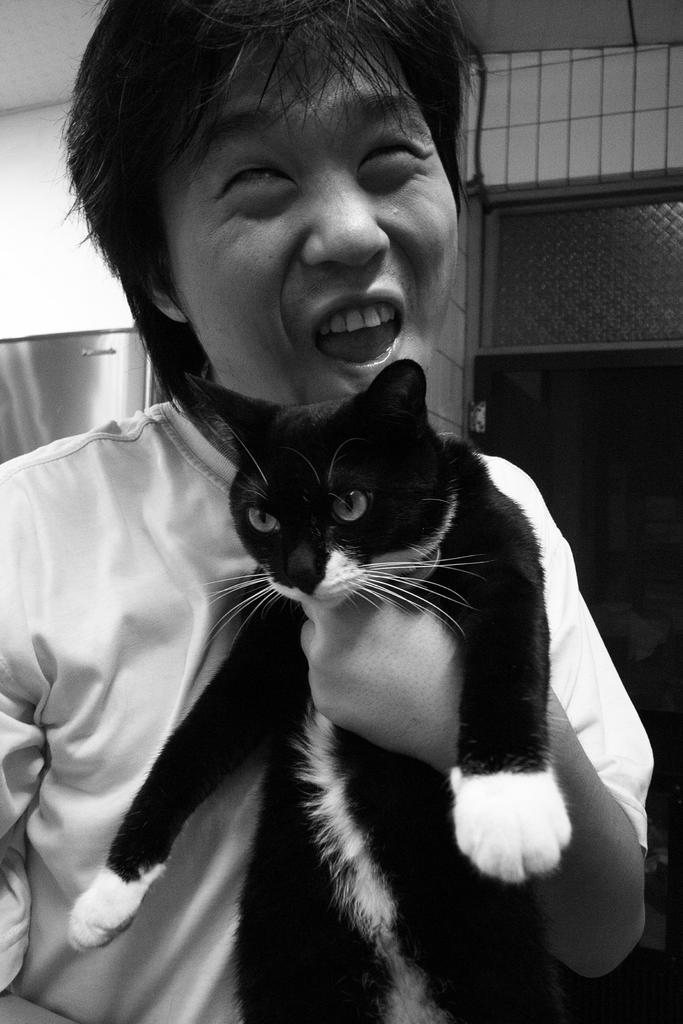What is the color scheme of the image? The image is black and white. Can you describe the person in the image? There is a person in the image, and they are standing. What is the person holding in their left hand? The person is holding a cat in their left hand. What can be seen in the background of the image? There is a wall, a door, and a window in the background of the image. What type of rhythm is the person running to in the image? There is no indication that the person is running in the image, and therefore no rhythm can be associated with their actions. 